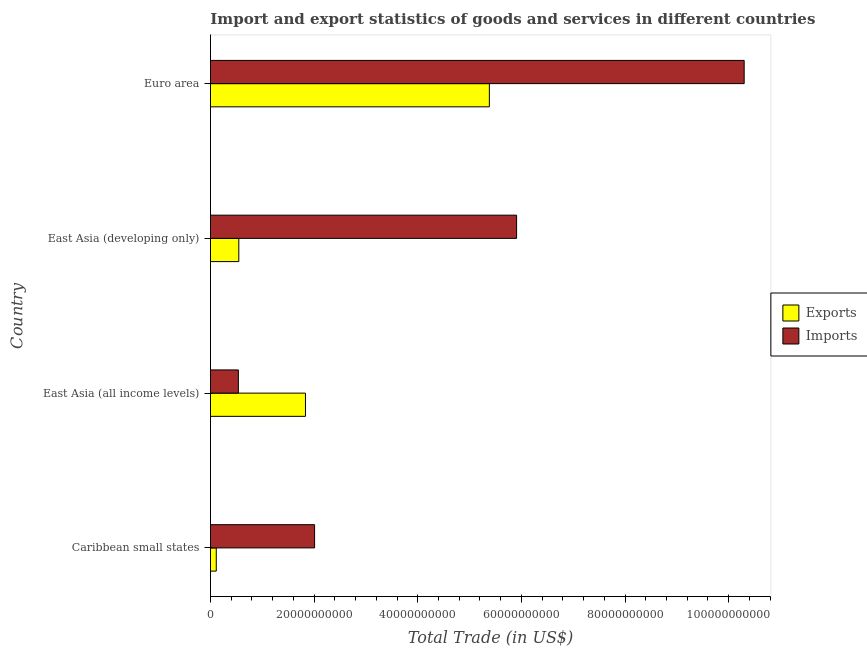How many different coloured bars are there?
Ensure brevity in your answer.  2. How many groups of bars are there?
Provide a succinct answer. 4. Are the number of bars on each tick of the Y-axis equal?
Your answer should be compact. Yes. How many bars are there on the 1st tick from the bottom?
Provide a short and direct response. 2. What is the label of the 1st group of bars from the top?
Make the answer very short. Euro area. What is the imports of goods and services in East Asia (all income levels)?
Make the answer very short. 5.39e+09. Across all countries, what is the maximum export of goods and services?
Provide a succinct answer. 5.38e+1. Across all countries, what is the minimum export of goods and services?
Provide a succinct answer. 1.12e+09. In which country was the export of goods and services maximum?
Make the answer very short. Euro area. In which country was the export of goods and services minimum?
Your response must be concise. Caribbean small states. What is the total imports of goods and services in the graph?
Offer a terse response. 1.88e+11. What is the difference between the export of goods and services in Caribbean small states and that in Euro area?
Your response must be concise. -5.27e+1. What is the difference between the export of goods and services in Caribbean small states and the imports of goods and services in East Asia (developing only)?
Make the answer very short. -5.80e+1. What is the average imports of goods and services per country?
Your response must be concise. 4.69e+1. What is the difference between the export of goods and services and imports of goods and services in East Asia (all income levels)?
Offer a terse response. 1.29e+1. In how many countries, is the imports of goods and services greater than 20000000000 US$?
Offer a terse response. 3. What is the ratio of the imports of goods and services in Caribbean small states to that in East Asia (developing only)?
Offer a terse response. 0.34. Is the difference between the imports of goods and services in Caribbean small states and Euro area greater than the difference between the export of goods and services in Caribbean small states and Euro area?
Offer a very short reply. No. What is the difference between the highest and the second highest export of goods and services?
Your answer should be compact. 3.55e+1. What is the difference between the highest and the lowest imports of goods and services?
Give a very brief answer. 9.76e+1. What does the 2nd bar from the top in East Asia (developing only) represents?
Your answer should be compact. Exports. What does the 1st bar from the bottom in East Asia (developing only) represents?
Provide a succinct answer. Exports. How many bars are there?
Give a very brief answer. 8. What is the difference between two consecutive major ticks on the X-axis?
Your answer should be compact. 2.00e+1. Are the values on the major ticks of X-axis written in scientific E-notation?
Ensure brevity in your answer.  No. Does the graph contain grids?
Offer a very short reply. No. Where does the legend appear in the graph?
Offer a very short reply. Center right. How are the legend labels stacked?
Provide a succinct answer. Vertical. What is the title of the graph?
Your response must be concise. Import and export statistics of goods and services in different countries. What is the label or title of the X-axis?
Your response must be concise. Total Trade (in US$). What is the label or title of the Y-axis?
Your response must be concise. Country. What is the Total Trade (in US$) in Exports in Caribbean small states?
Keep it short and to the point. 1.12e+09. What is the Total Trade (in US$) in Imports in Caribbean small states?
Offer a very short reply. 2.01e+1. What is the Total Trade (in US$) in Exports in East Asia (all income levels)?
Make the answer very short. 1.83e+1. What is the Total Trade (in US$) of Imports in East Asia (all income levels)?
Your answer should be compact. 5.39e+09. What is the Total Trade (in US$) in Exports in East Asia (developing only)?
Your response must be concise. 5.47e+09. What is the Total Trade (in US$) in Imports in East Asia (developing only)?
Provide a short and direct response. 5.91e+1. What is the Total Trade (in US$) of Exports in Euro area?
Give a very brief answer. 5.38e+1. What is the Total Trade (in US$) of Imports in Euro area?
Your answer should be very brief. 1.03e+11. Across all countries, what is the maximum Total Trade (in US$) in Exports?
Give a very brief answer. 5.38e+1. Across all countries, what is the maximum Total Trade (in US$) of Imports?
Keep it short and to the point. 1.03e+11. Across all countries, what is the minimum Total Trade (in US$) of Exports?
Your answer should be very brief. 1.12e+09. Across all countries, what is the minimum Total Trade (in US$) in Imports?
Ensure brevity in your answer.  5.39e+09. What is the total Total Trade (in US$) of Exports in the graph?
Make the answer very short. 7.87e+1. What is the total Total Trade (in US$) in Imports in the graph?
Keep it short and to the point. 1.88e+11. What is the difference between the Total Trade (in US$) in Exports in Caribbean small states and that in East Asia (all income levels)?
Give a very brief answer. -1.72e+1. What is the difference between the Total Trade (in US$) in Imports in Caribbean small states and that in East Asia (all income levels)?
Your response must be concise. 1.47e+1. What is the difference between the Total Trade (in US$) in Exports in Caribbean small states and that in East Asia (developing only)?
Your answer should be compact. -4.35e+09. What is the difference between the Total Trade (in US$) in Imports in Caribbean small states and that in East Asia (developing only)?
Give a very brief answer. -3.90e+1. What is the difference between the Total Trade (in US$) of Exports in Caribbean small states and that in Euro area?
Give a very brief answer. -5.27e+1. What is the difference between the Total Trade (in US$) in Imports in Caribbean small states and that in Euro area?
Provide a short and direct response. -8.29e+1. What is the difference between the Total Trade (in US$) of Exports in East Asia (all income levels) and that in East Asia (developing only)?
Your answer should be compact. 1.29e+1. What is the difference between the Total Trade (in US$) of Imports in East Asia (all income levels) and that in East Asia (developing only)?
Ensure brevity in your answer.  -5.37e+1. What is the difference between the Total Trade (in US$) in Exports in East Asia (all income levels) and that in Euro area?
Offer a very short reply. -3.55e+1. What is the difference between the Total Trade (in US$) in Imports in East Asia (all income levels) and that in Euro area?
Make the answer very short. -9.76e+1. What is the difference between the Total Trade (in US$) in Exports in East Asia (developing only) and that in Euro area?
Offer a terse response. -4.84e+1. What is the difference between the Total Trade (in US$) of Imports in East Asia (developing only) and that in Euro area?
Provide a short and direct response. -4.39e+1. What is the difference between the Total Trade (in US$) in Exports in Caribbean small states and the Total Trade (in US$) in Imports in East Asia (all income levels)?
Provide a succinct answer. -4.27e+09. What is the difference between the Total Trade (in US$) of Exports in Caribbean small states and the Total Trade (in US$) of Imports in East Asia (developing only)?
Provide a succinct answer. -5.80e+1. What is the difference between the Total Trade (in US$) of Exports in Caribbean small states and the Total Trade (in US$) of Imports in Euro area?
Your answer should be compact. -1.02e+11. What is the difference between the Total Trade (in US$) of Exports in East Asia (all income levels) and the Total Trade (in US$) of Imports in East Asia (developing only)?
Make the answer very short. -4.07e+1. What is the difference between the Total Trade (in US$) in Exports in East Asia (all income levels) and the Total Trade (in US$) in Imports in Euro area?
Ensure brevity in your answer.  -8.47e+1. What is the difference between the Total Trade (in US$) in Exports in East Asia (developing only) and the Total Trade (in US$) in Imports in Euro area?
Your answer should be very brief. -9.75e+1. What is the average Total Trade (in US$) in Exports per country?
Provide a short and direct response. 1.97e+1. What is the average Total Trade (in US$) in Imports per country?
Make the answer very short. 4.69e+1. What is the difference between the Total Trade (in US$) of Exports and Total Trade (in US$) of Imports in Caribbean small states?
Your answer should be very brief. -1.90e+1. What is the difference between the Total Trade (in US$) in Exports and Total Trade (in US$) in Imports in East Asia (all income levels)?
Give a very brief answer. 1.29e+1. What is the difference between the Total Trade (in US$) in Exports and Total Trade (in US$) in Imports in East Asia (developing only)?
Give a very brief answer. -5.36e+1. What is the difference between the Total Trade (in US$) of Exports and Total Trade (in US$) of Imports in Euro area?
Your answer should be very brief. -4.92e+1. What is the ratio of the Total Trade (in US$) in Exports in Caribbean small states to that in East Asia (all income levels)?
Your response must be concise. 0.06. What is the ratio of the Total Trade (in US$) in Imports in Caribbean small states to that in East Asia (all income levels)?
Provide a succinct answer. 3.73. What is the ratio of the Total Trade (in US$) of Exports in Caribbean small states to that in East Asia (developing only)?
Your answer should be very brief. 0.2. What is the ratio of the Total Trade (in US$) of Imports in Caribbean small states to that in East Asia (developing only)?
Provide a succinct answer. 0.34. What is the ratio of the Total Trade (in US$) of Exports in Caribbean small states to that in Euro area?
Your response must be concise. 0.02. What is the ratio of the Total Trade (in US$) of Imports in Caribbean small states to that in Euro area?
Your response must be concise. 0.2. What is the ratio of the Total Trade (in US$) of Exports in East Asia (all income levels) to that in East Asia (developing only)?
Make the answer very short. 3.35. What is the ratio of the Total Trade (in US$) of Imports in East Asia (all income levels) to that in East Asia (developing only)?
Offer a very short reply. 0.09. What is the ratio of the Total Trade (in US$) of Exports in East Asia (all income levels) to that in Euro area?
Your answer should be compact. 0.34. What is the ratio of the Total Trade (in US$) of Imports in East Asia (all income levels) to that in Euro area?
Make the answer very short. 0.05. What is the ratio of the Total Trade (in US$) of Exports in East Asia (developing only) to that in Euro area?
Provide a succinct answer. 0.1. What is the ratio of the Total Trade (in US$) of Imports in East Asia (developing only) to that in Euro area?
Give a very brief answer. 0.57. What is the difference between the highest and the second highest Total Trade (in US$) of Exports?
Your answer should be compact. 3.55e+1. What is the difference between the highest and the second highest Total Trade (in US$) in Imports?
Provide a short and direct response. 4.39e+1. What is the difference between the highest and the lowest Total Trade (in US$) in Exports?
Ensure brevity in your answer.  5.27e+1. What is the difference between the highest and the lowest Total Trade (in US$) of Imports?
Offer a terse response. 9.76e+1. 